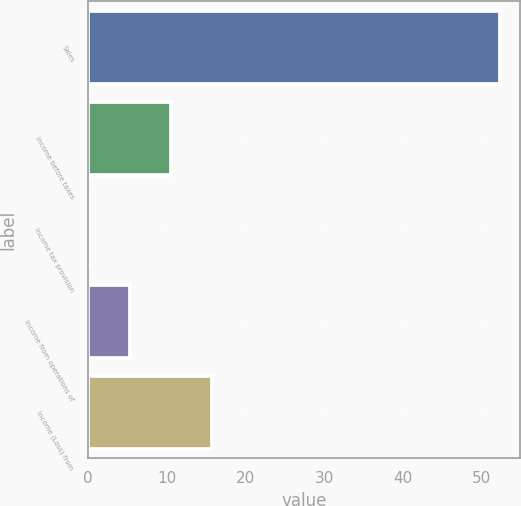<chart> <loc_0><loc_0><loc_500><loc_500><bar_chart><fcel>Sales<fcel>Income before taxes<fcel>Income tax provision<fcel>Income from operations of<fcel>Income (Loss) from<nl><fcel>52.3<fcel>10.62<fcel>0.2<fcel>5.41<fcel>15.83<nl></chart> 